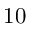<formula> <loc_0><loc_0><loc_500><loc_500>1 0</formula> 